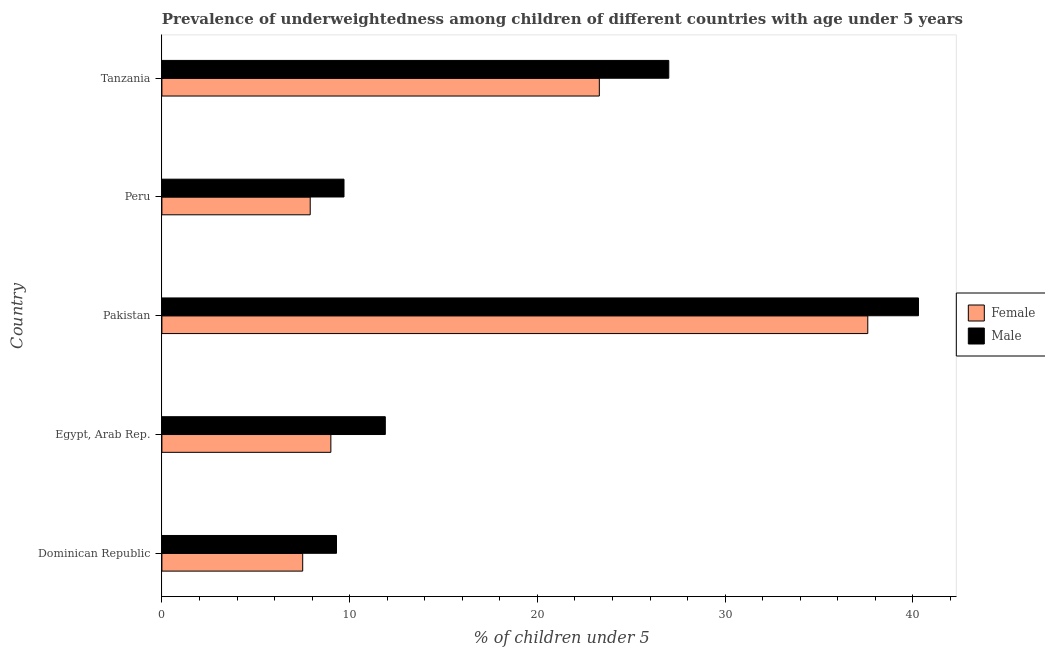How many different coloured bars are there?
Give a very brief answer. 2. How many groups of bars are there?
Keep it short and to the point. 5. Are the number of bars per tick equal to the number of legend labels?
Give a very brief answer. Yes. Are the number of bars on each tick of the Y-axis equal?
Offer a terse response. Yes. How many bars are there on the 2nd tick from the top?
Keep it short and to the point. 2. What is the label of the 3rd group of bars from the top?
Offer a very short reply. Pakistan. What is the percentage of underweighted male children in Pakistan?
Provide a succinct answer. 40.3. Across all countries, what is the maximum percentage of underweighted female children?
Provide a succinct answer. 37.6. Across all countries, what is the minimum percentage of underweighted male children?
Keep it short and to the point. 9.3. In which country was the percentage of underweighted female children maximum?
Offer a very short reply. Pakistan. In which country was the percentage of underweighted male children minimum?
Your answer should be compact. Dominican Republic. What is the total percentage of underweighted female children in the graph?
Your response must be concise. 85.3. What is the difference between the percentage of underweighted female children in Pakistan and that in Peru?
Keep it short and to the point. 29.7. What is the difference between the percentage of underweighted female children in Pakistan and the percentage of underweighted male children in Egypt, Arab Rep.?
Your answer should be compact. 25.7. What is the average percentage of underweighted female children per country?
Keep it short and to the point. 17.06. In how many countries, is the percentage of underweighted male children greater than 34 %?
Ensure brevity in your answer.  1. What is the ratio of the percentage of underweighted female children in Pakistan to that in Tanzania?
Make the answer very short. 1.61. Is the percentage of underweighted male children in Dominican Republic less than that in Peru?
Your answer should be very brief. Yes. What is the difference between the highest and the lowest percentage of underweighted female children?
Provide a succinct answer. 30.1. Is the sum of the percentage of underweighted male children in Dominican Republic and Tanzania greater than the maximum percentage of underweighted female children across all countries?
Offer a very short reply. No. What does the 2nd bar from the top in Pakistan represents?
Provide a succinct answer. Female. What does the 1st bar from the bottom in Egypt, Arab Rep. represents?
Give a very brief answer. Female. How many countries are there in the graph?
Your answer should be very brief. 5. What is the difference between two consecutive major ticks on the X-axis?
Provide a succinct answer. 10. Where does the legend appear in the graph?
Provide a short and direct response. Center right. How are the legend labels stacked?
Make the answer very short. Vertical. What is the title of the graph?
Provide a succinct answer. Prevalence of underweightedness among children of different countries with age under 5 years. What is the label or title of the X-axis?
Keep it short and to the point.  % of children under 5. What is the label or title of the Y-axis?
Keep it short and to the point. Country. What is the  % of children under 5 of Male in Dominican Republic?
Offer a very short reply. 9.3. What is the  % of children under 5 in Female in Egypt, Arab Rep.?
Ensure brevity in your answer.  9. What is the  % of children under 5 of Male in Egypt, Arab Rep.?
Give a very brief answer. 11.9. What is the  % of children under 5 in Female in Pakistan?
Give a very brief answer. 37.6. What is the  % of children under 5 of Male in Pakistan?
Provide a short and direct response. 40.3. What is the  % of children under 5 in Female in Peru?
Your answer should be compact. 7.9. What is the  % of children under 5 of Male in Peru?
Your answer should be compact. 9.7. What is the  % of children under 5 in Female in Tanzania?
Provide a short and direct response. 23.3. Across all countries, what is the maximum  % of children under 5 of Female?
Provide a short and direct response. 37.6. Across all countries, what is the maximum  % of children under 5 of Male?
Ensure brevity in your answer.  40.3. Across all countries, what is the minimum  % of children under 5 of Female?
Make the answer very short. 7.5. Across all countries, what is the minimum  % of children under 5 in Male?
Your answer should be compact. 9.3. What is the total  % of children under 5 of Female in the graph?
Make the answer very short. 85.3. What is the total  % of children under 5 of Male in the graph?
Keep it short and to the point. 98.2. What is the difference between the  % of children under 5 of Female in Dominican Republic and that in Egypt, Arab Rep.?
Keep it short and to the point. -1.5. What is the difference between the  % of children under 5 of Female in Dominican Republic and that in Pakistan?
Offer a terse response. -30.1. What is the difference between the  % of children under 5 in Male in Dominican Republic and that in Pakistan?
Offer a very short reply. -31. What is the difference between the  % of children under 5 in Male in Dominican Republic and that in Peru?
Give a very brief answer. -0.4. What is the difference between the  % of children under 5 of Female in Dominican Republic and that in Tanzania?
Offer a very short reply. -15.8. What is the difference between the  % of children under 5 of Male in Dominican Republic and that in Tanzania?
Offer a very short reply. -17.7. What is the difference between the  % of children under 5 of Female in Egypt, Arab Rep. and that in Pakistan?
Your answer should be very brief. -28.6. What is the difference between the  % of children under 5 in Male in Egypt, Arab Rep. and that in Pakistan?
Your response must be concise. -28.4. What is the difference between the  % of children under 5 of Male in Egypt, Arab Rep. and that in Peru?
Provide a succinct answer. 2.2. What is the difference between the  % of children under 5 of Female in Egypt, Arab Rep. and that in Tanzania?
Offer a very short reply. -14.3. What is the difference between the  % of children under 5 of Male in Egypt, Arab Rep. and that in Tanzania?
Give a very brief answer. -15.1. What is the difference between the  % of children under 5 in Female in Pakistan and that in Peru?
Offer a terse response. 29.7. What is the difference between the  % of children under 5 in Male in Pakistan and that in Peru?
Your answer should be compact. 30.6. What is the difference between the  % of children under 5 in Female in Pakistan and that in Tanzania?
Give a very brief answer. 14.3. What is the difference between the  % of children under 5 of Male in Pakistan and that in Tanzania?
Your response must be concise. 13.3. What is the difference between the  % of children under 5 of Female in Peru and that in Tanzania?
Keep it short and to the point. -15.4. What is the difference between the  % of children under 5 in Male in Peru and that in Tanzania?
Offer a very short reply. -17.3. What is the difference between the  % of children under 5 of Female in Dominican Republic and the  % of children under 5 of Male in Egypt, Arab Rep.?
Provide a succinct answer. -4.4. What is the difference between the  % of children under 5 of Female in Dominican Republic and the  % of children under 5 of Male in Pakistan?
Ensure brevity in your answer.  -32.8. What is the difference between the  % of children under 5 of Female in Dominican Republic and the  % of children under 5 of Male in Tanzania?
Keep it short and to the point. -19.5. What is the difference between the  % of children under 5 of Female in Egypt, Arab Rep. and the  % of children under 5 of Male in Pakistan?
Your response must be concise. -31.3. What is the difference between the  % of children under 5 in Female in Egypt, Arab Rep. and the  % of children under 5 in Male in Tanzania?
Keep it short and to the point. -18. What is the difference between the  % of children under 5 in Female in Pakistan and the  % of children under 5 in Male in Peru?
Offer a terse response. 27.9. What is the difference between the  % of children under 5 of Female in Peru and the  % of children under 5 of Male in Tanzania?
Make the answer very short. -19.1. What is the average  % of children under 5 of Female per country?
Offer a very short reply. 17.06. What is the average  % of children under 5 in Male per country?
Provide a short and direct response. 19.64. What is the difference between the  % of children under 5 in Female and  % of children under 5 in Male in Dominican Republic?
Offer a very short reply. -1.8. What is the difference between the  % of children under 5 of Female and  % of children under 5 of Male in Egypt, Arab Rep.?
Make the answer very short. -2.9. What is the difference between the  % of children under 5 in Female and  % of children under 5 in Male in Tanzania?
Your response must be concise. -3.7. What is the ratio of the  % of children under 5 of Female in Dominican Republic to that in Egypt, Arab Rep.?
Offer a terse response. 0.83. What is the ratio of the  % of children under 5 in Male in Dominican Republic to that in Egypt, Arab Rep.?
Ensure brevity in your answer.  0.78. What is the ratio of the  % of children under 5 in Female in Dominican Republic to that in Pakistan?
Provide a succinct answer. 0.2. What is the ratio of the  % of children under 5 of Male in Dominican Republic to that in Pakistan?
Give a very brief answer. 0.23. What is the ratio of the  % of children under 5 in Female in Dominican Republic to that in Peru?
Keep it short and to the point. 0.95. What is the ratio of the  % of children under 5 of Male in Dominican Republic to that in Peru?
Give a very brief answer. 0.96. What is the ratio of the  % of children under 5 of Female in Dominican Republic to that in Tanzania?
Offer a terse response. 0.32. What is the ratio of the  % of children under 5 of Male in Dominican Republic to that in Tanzania?
Give a very brief answer. 0.34. What is the ratio of the  % of children under 5 in Female in Egypt, Arab Rep. to that in Pakistan?
Give a very brief answer. 0.24. What is the ratio of the  % of children under 5 of Male in Egypt, Arab Rep. to that in Pakistan?
Offer a terse response. 0.3. What is the ratio of the  % of children under 5 of Female in Egypt, Arab Rep. to that in Peru?
Offer a terse response. 1.14. What is the ratio of the  % of children under 5 of Male in Egypt, Arab Rep. to that in Peru?
Keep it short and to the point. 1.23. What is the ratio of the  % of children under 5 in Female in Egypt, Arab Rep. to that in Tanzania?
Provide a short and direct response. 0.39. What is the ratio of the  % of children under 5 in Male in Egypt, Arab Rep. to that in Tanzania?
Provide a short and direct response. 0.44. What is the ratio of the  % of children under 5 in Female in Pakistan to that in Peru?
Keep it short and to the point. 4.76. What is the ratio of the  % of children under 5 in Male in Pakistan to that in Peru?
Your answer should be very brief. 4.15. What is the ratio of the  % of children under 5 in Female in Pakistan to that in Tanzania?
Offer a very short reply. 1.61. What is the ratio of the  % of children under 5 in Male in Pakistan to that in Tanzania?
Ensure brevity in your answer.  1.49. What is the ratio of the  % of children under 5 in Female in Peru to that in Tanzania?
Your answer should be compact. 0.34. What is the ratio of the  % of children under 5 in Male in Peru to that in Tanzania?
Make the answer very short. 0.36. What is the difference between the highest and the second highest  % of children under 5 in Female?
Offer a terse response. 14.3. What is the difference between the highest and the lowest  % of children under 5 in Female?
Make the answer very short. 30.1. What is the difference between the highest and the lowest  % of children under 5 of Male?
Keep it short and to the point. 31. 